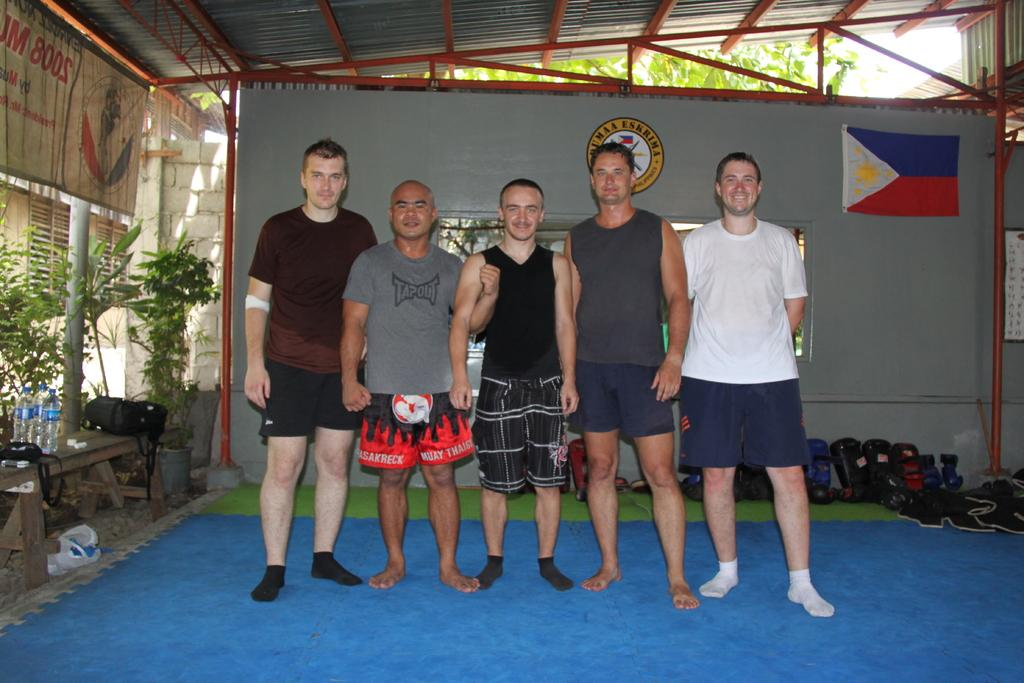<image>
Write a terse but informative summary of the picture. A man in  tapout t-shirt posing with some guys. 